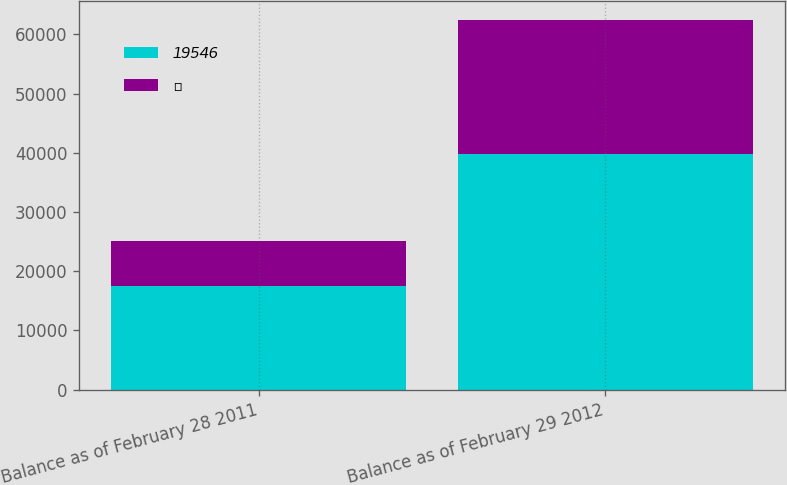<chart> <loc_0><loc_0><loc_500><loc_500><stacked_bar_chart><ecel><fcel>Balance as of February 28 2011<fcel>Balance as of February 29 2012<nl><fcel>19546<fcel>17528<fcel>39774<nl><fcel>ʊ<fcel>7529<fcel>22685<nl></chart> 